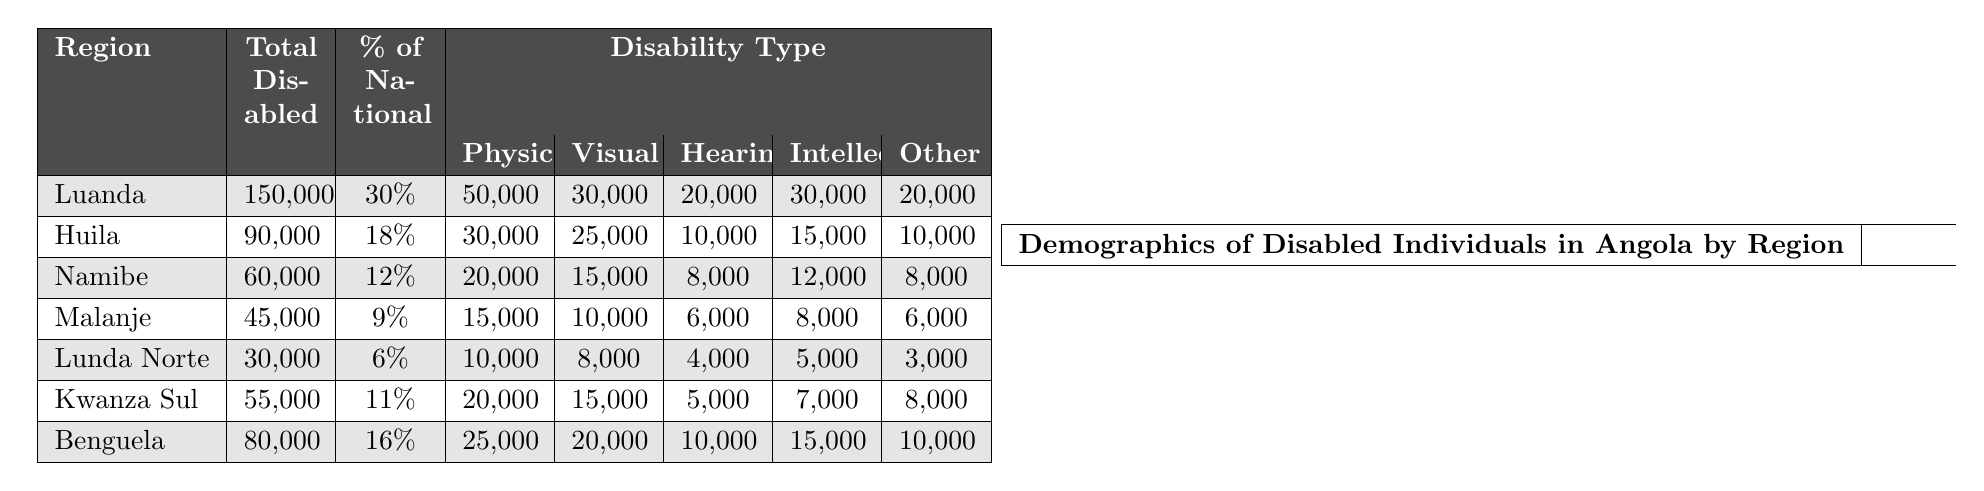What is the total number of disabled individuals in Luanda? The table shows that the total number of disabled individuals in Luanda is given as 150,000.
Answer: 150,000 What percentage of the national disabled population does Huila represent? According to the table, Huila represents 18% of the national disabled population.
Answer: 18% How many individuals have hearing disabilities in Benguela? From the table, the number of individuals with hearing disabilities in Benguela is listed as 10,000.
Answer: 10,000 What is the combined total of individuals with intellectual disabilities in Luanda and Benguela? First, find the intellectual disabilities in Luanda (30,000) and Benguela (15,000). Adding these gives 30,000 + 15,000 = 45,000.
Answer: 45,000 Is there a higher number of physical disabilities in Huila or Malanje? In Huila, the number of physical disabilities is 30,000, and in Malanje, it is 15,000. Since 30,000 is greater than 15,000, Huila has more physical disabilities.
Answer: Yes What is the total number of disabled individuals across all regions listed in the table? To find the total, we add the numbers from each region: 150,000 + 90,000 + 60,000 + 45,000 + 30,000 + 55,000 + 80,000 = 510,000.
Answer: 510,000 Which region has the lowest percentage of the national disabled population? By checking the table, Lunda Norte has the lowest percentage at 6%.
Answer: Lunda Norte How many physical disabilities are there in Angolan regions combined? Summing the physical disabilities from all regions gives: 50,000 (Luanda) + 30,000 (Huila) + 20,000 (Namibe) + 15,000 (Malanje) + 10,000 (Lunda Norte) + 20,000 (Kwanza Sul) + 25,000 (Benguela) = 170,000.
Answer: 170,000 Which region has both the highest total of disabled individuals and the highest number of visual disabilities? The region with the highest total number of disabled individuals is Luanda with 150,000, and for visual disabilities, it also has the highest number at 30,000.
Answer: Luanda In which region do individuals with other disabilities outnumber those with hearing disabilities? By analyzing the data, in Luanda (20,000), Huila (10,000), Kwanza Sul (8,000), and Benguela (10,000) for other compared to hearing disabilities: Luanda, Huila, Kwanza Sul, and Benguela have more 'Other' than 'Hearing.'
Answer: Luanda, Huila, Kwanza Sul, and Benguela 